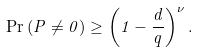Convert formula to latex. <formula><loc_0><loc_0><loc_500><loc_500>\Pr \left ( P \neq 0 \right ) \geq \left ( 1 - \frac { d } { q } \right ) ^ { \nu } .</formula> 